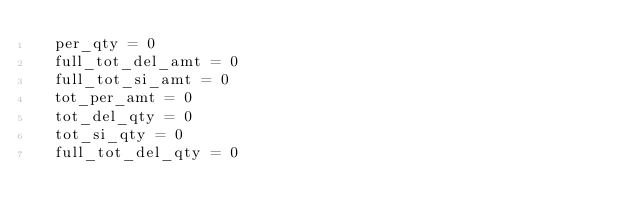<code> <loc_0><loc_0><loc_500><loc_500><_Python_>	per_qty = 0
	full_tot_del_amt = 0
	full_tot_si_amt = 0
	tot_per_amt = 0
	tot_del_qty = 0
	tot_si_qty = 0
	full_tot_del_qty = 0</code> 